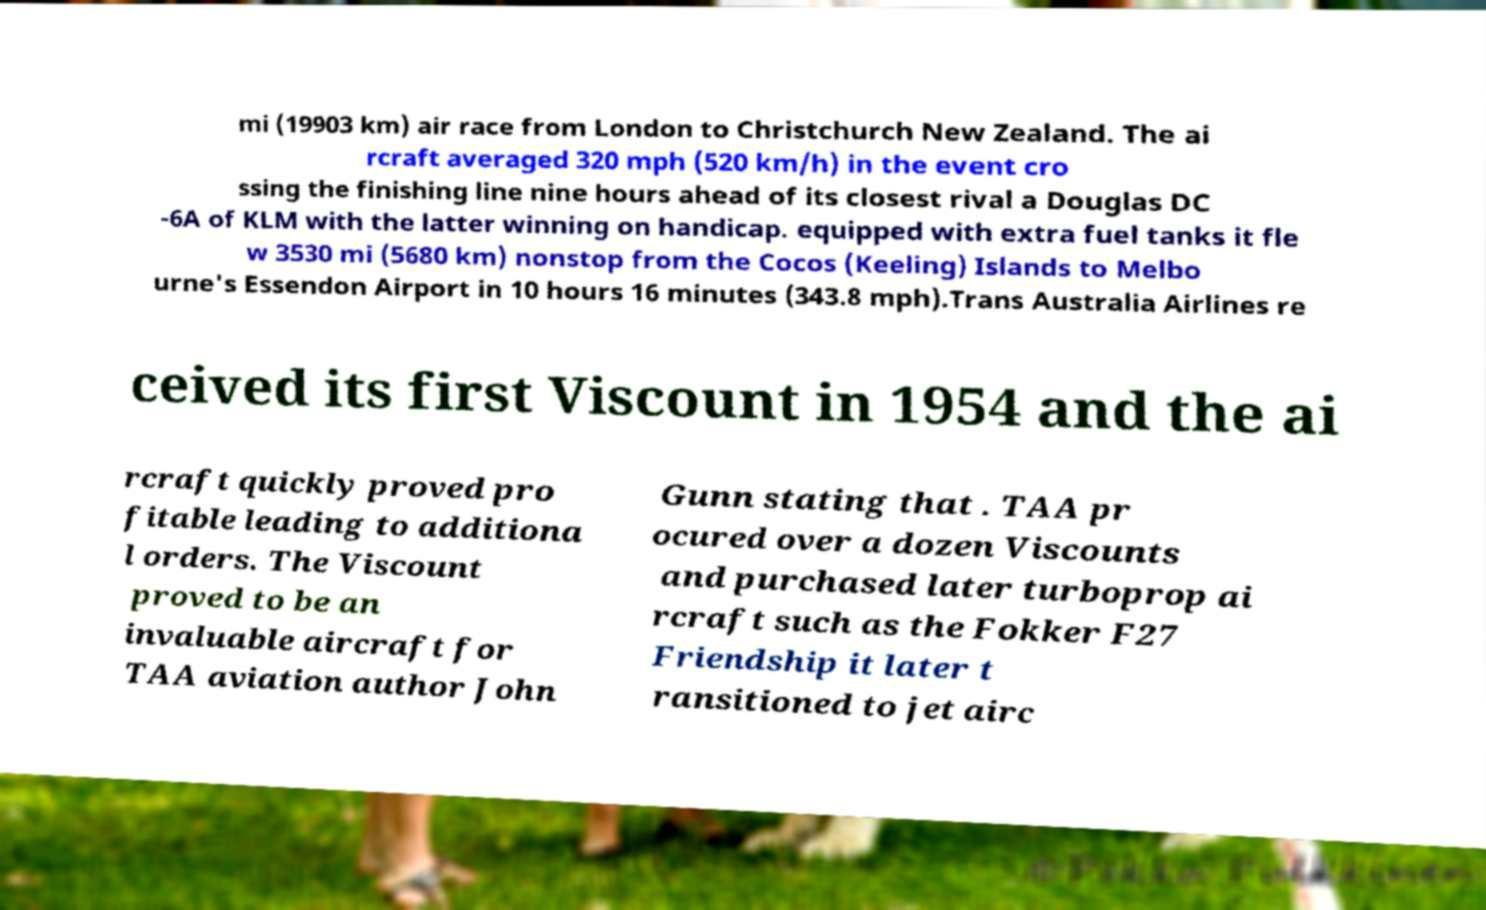Please read and relay the text visible in this image. What does it say? mi (19903 km) air race from London to Christchurch New Zealand. The ai rcraft averaged 320 mph (520 km/h) in the event cro ssing the finishing line nine hours ahead of its closest rival a Douglas DC -6A of KLM with the latter winning on handicap. equipped with extra fuel tanks it fle w 3530 mi (5680 km) nonstop from the Cocos (Keeling) Islands to Melbo urne's Essendon Airport in 10 hours 16 minutes (343.8 mph).Trans Australia Airlines re ceived its first Viscount in 1954 and the ai rcraft quickly proved pro fitable leading to additiona l orders. The Viscount proved to be an invaluable aircraft for TAA aviation author John Gunn stating that . TAA pr ocured over a dozen Viscounts and purchased later turboprop ai rcraft such as the Fokker F27 Friendship it later t ransitioned to jet airc 